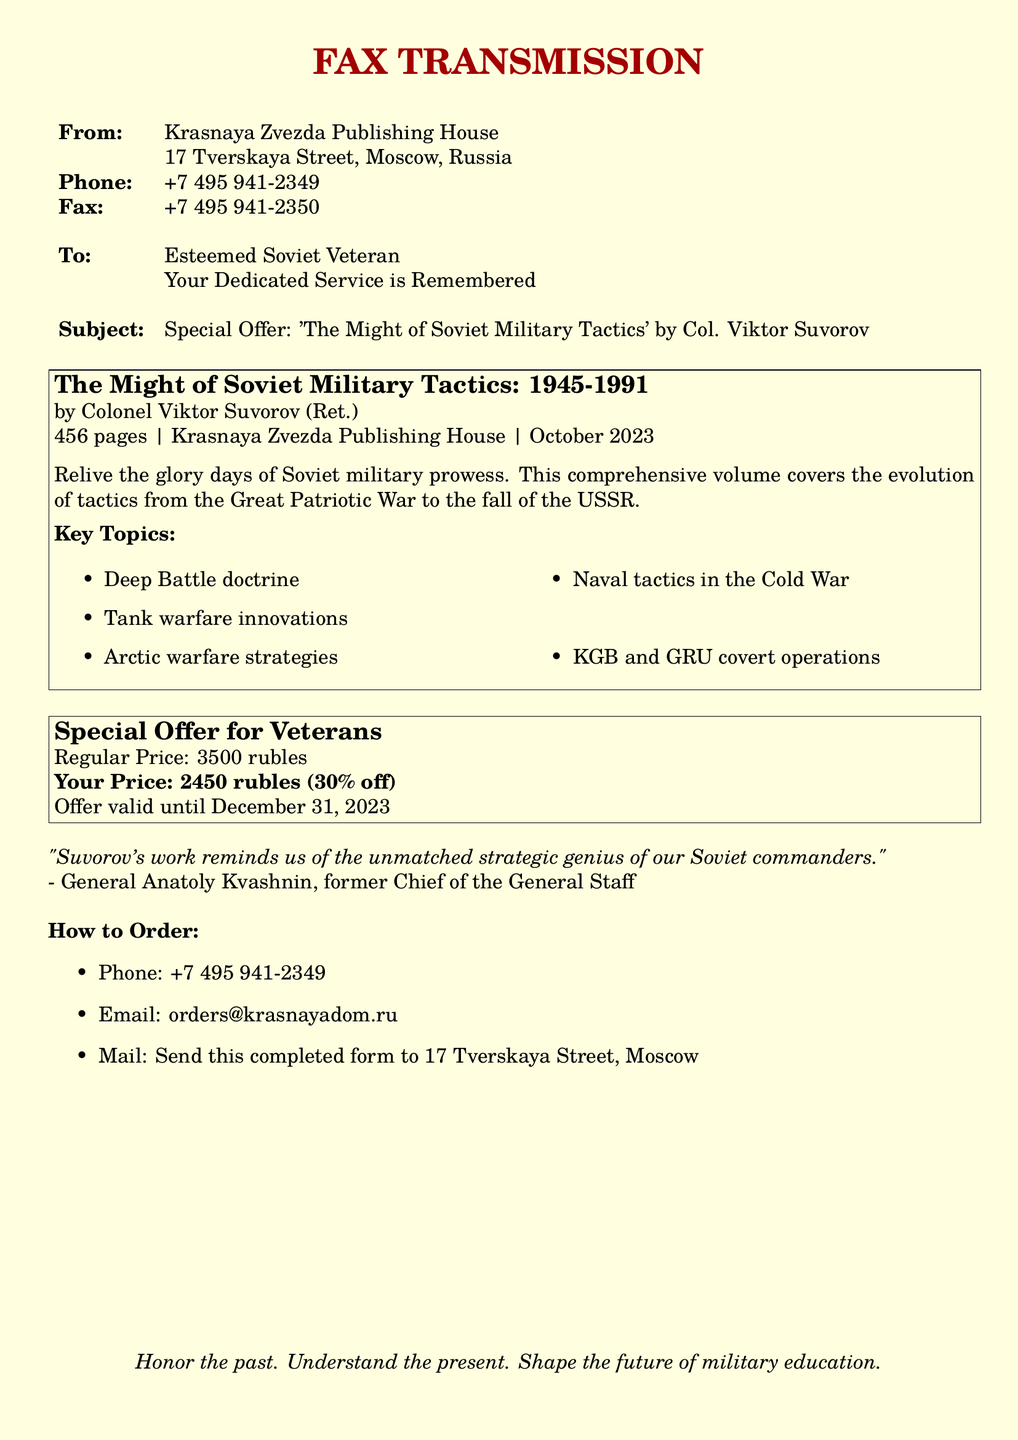What is the title of the book? The title of the book is explicitly mentioned in the subject line and the main section of the fax.
Answer: The Might of Soviet Military Tactics: 1945-1991 Who is the author of the book? The author's name is provided directly below the title.
Answer: Colonel Viktor Suvorov (Ret.) What is the regular price of the book? The regular price is stated in the special offer section.
Answer: 3500 rubles What discount percentage is offered to veterans? The discount percentage is noted in the special offer section of the fax.
Answer: 30% Until when is the special offer valid? The validity of the special offer is specified clearly in the document.
Answer: December 31, 2023 What are the key topics covered in the book? A list of key topics is presented in the middle section of the document.
Answer: Deep Battle doctrine, Tank warfare innovations, Arctic warfare strategies, Naval tactics in the Cold War, KGB and GRU covert operations What is the phone number to order the book? The ordering phone number is provided in the "How to Order" section.
Answer: +7 495 941-2349 What type of publication is this document? The document's formatting and content indicate it is a fax advertisement.
Answer: Fax advertisement 